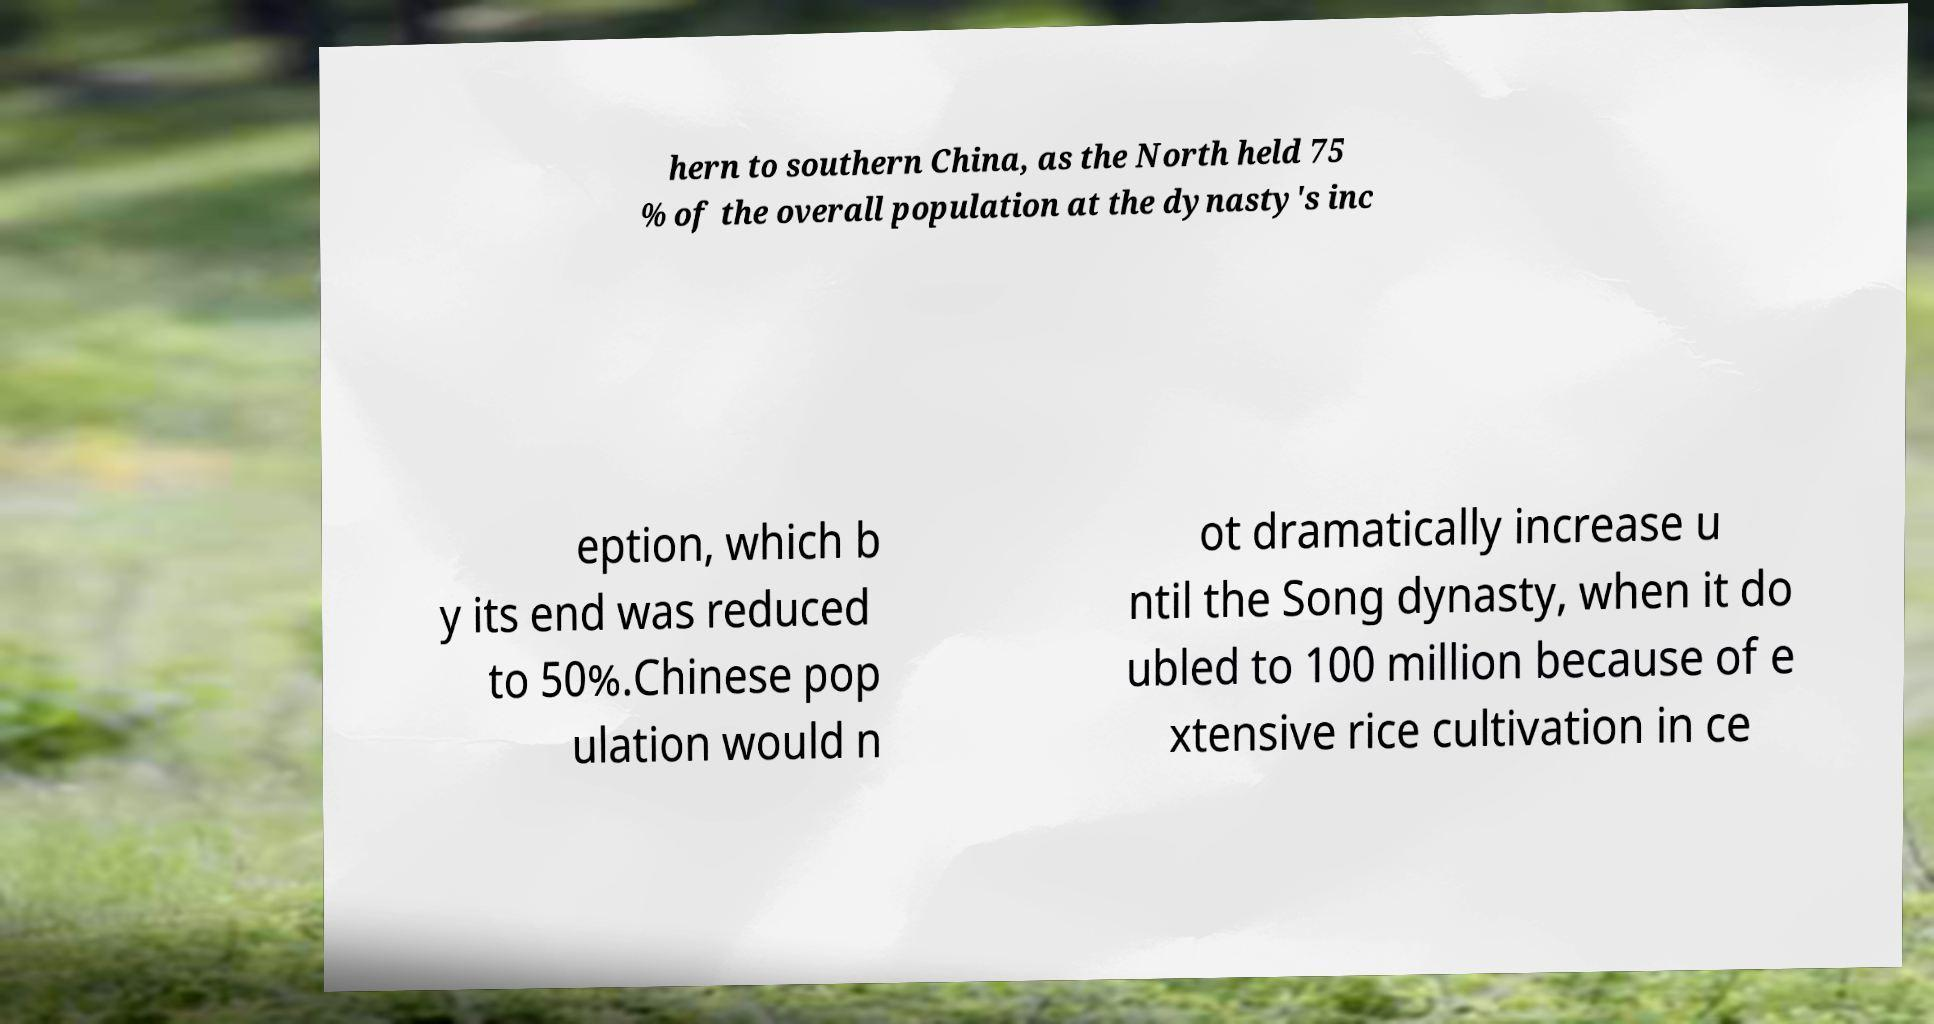Please identify and transcribe the text found in this image. hern to southern China, as the North held 75 % of the overall population at the dynasty's inc eption, which b y its end was reduced to 50%.Chinese pop ulation would n ot dramatically increase u ntil the Song dynasty, when it do ubled to 100 million because of e xtensive rice cultivation in ce 